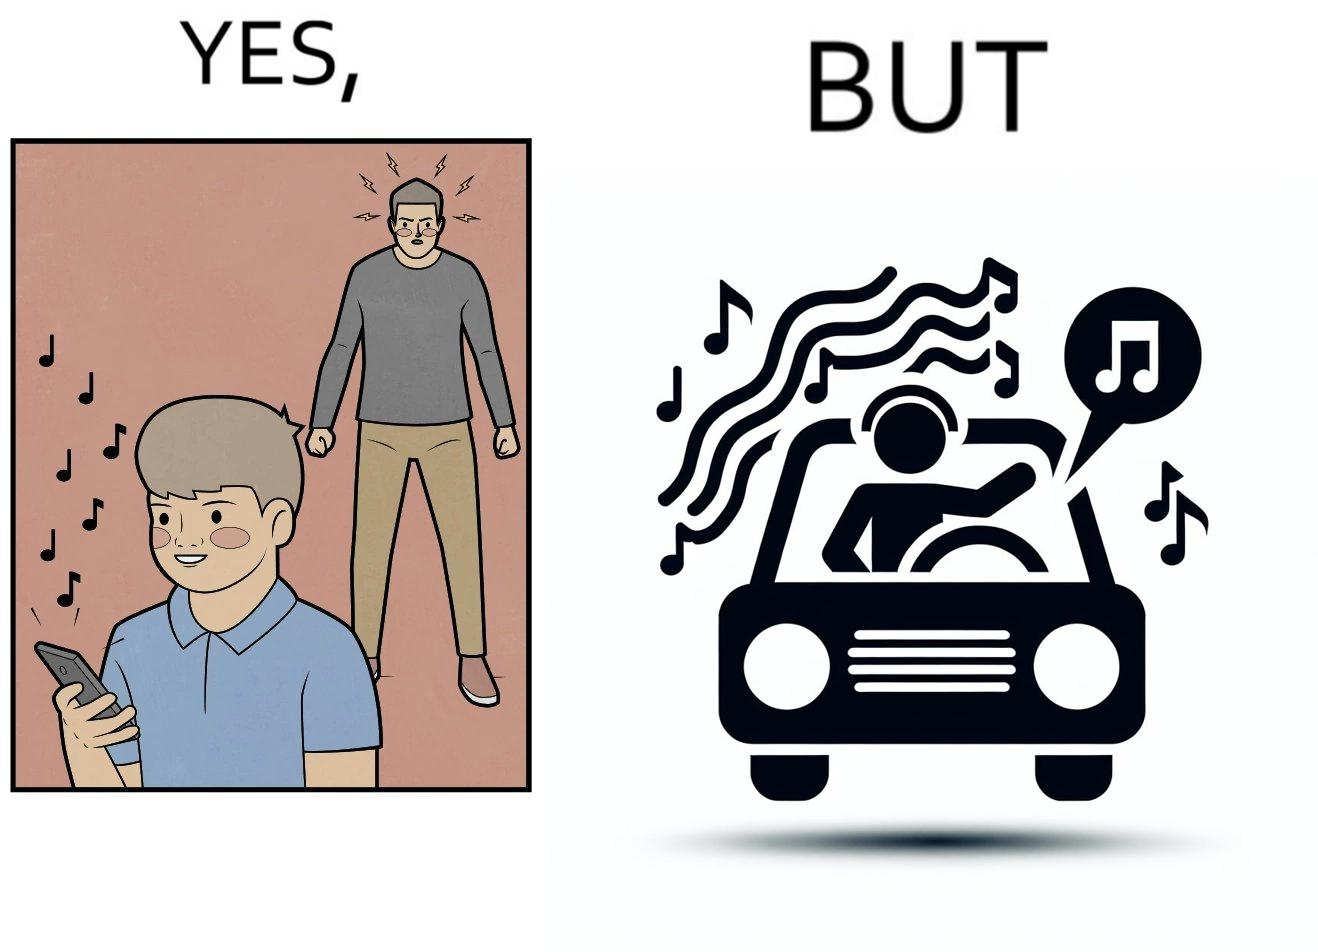Why is this image considered satirical? The image is funny because while the man does not like the boy playing music loudly on his phone, the man himself is okay with doing the same thing with his car and playing loud music in the car with the sound coming out of the car. 